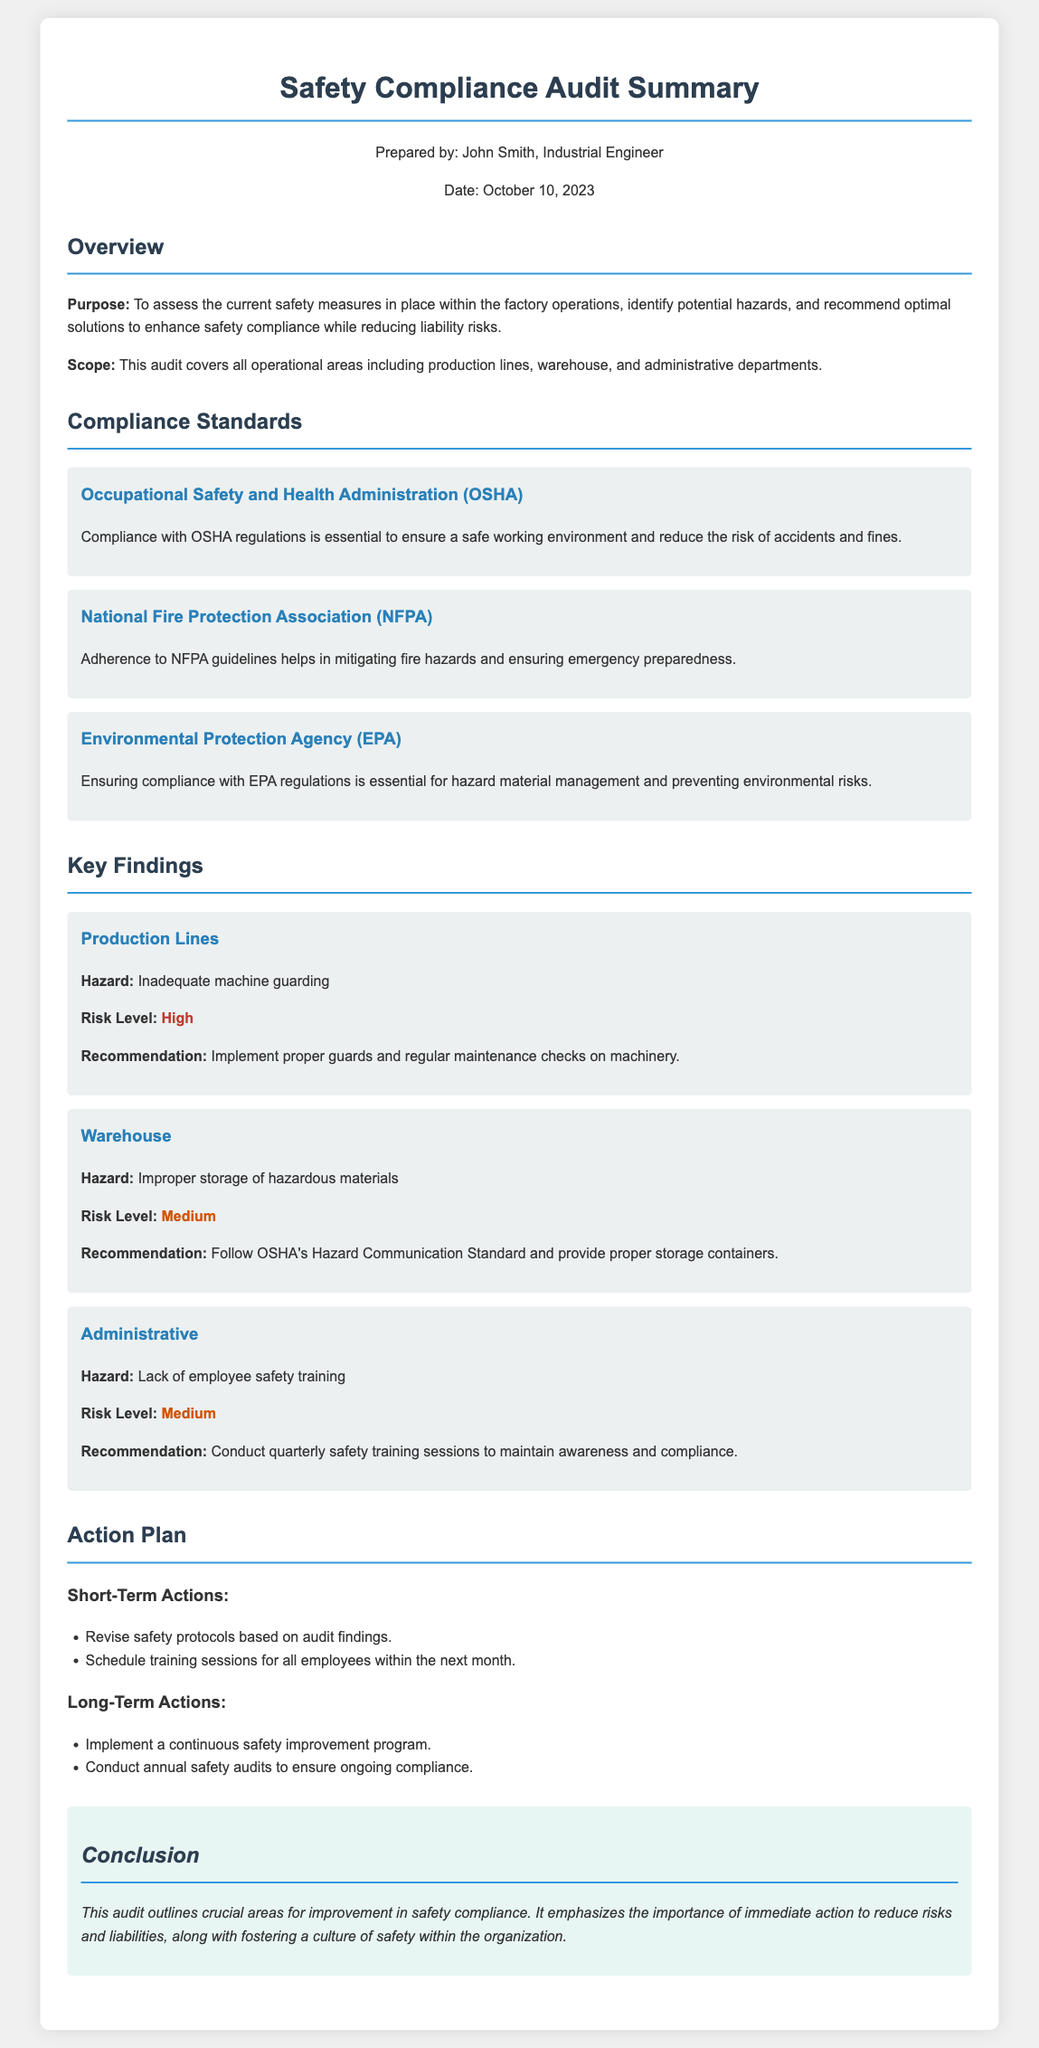What is the purpose of the audit? The purpose is to assess the current safety measures and recommend optimal solutions to enhance safety compliance while reducing liability risks.
Answer: To assess the current safety measures What is the date of the audit? The date of the audit is specifically mentioned in the document.
Answer: October 10, 2023 Which compliance standard focuses on fire hazards? The compliance standard addressing fire hazards is specified in the document.
Answer: National Fire Protection Association (NFPA) What is the risk level for inadequate machine guarding? The risk level for this specific hazard is mentioned clearly.
Answer: High What action is to be taken in the short term? A specific short-term action is noted in the audit.
Answer: Revise safety protocols What type of training is recommended for employees? The document specifies the type of training suggested for maintaining safety awareness.
Answer: Safety training How often should safety audits be conducted in the long term? The frequency for conducting safety audits is explicitly stated in the audit.
Answer: Annually What is the main conclusion of the audit? The conclusion outlines the overall importance and impact of safety compliance.
Answer: Immediate action to reduce risks What area had a medium risk due to improper storage? The area mentioned in the document related to this risk is clearly identified.
Answer: Warehouse What is a key recommendation for administrative hazards? The recommendation concerning administrative hazards is stated clearly.
Answer: Conduct quarterly safety training sessions 